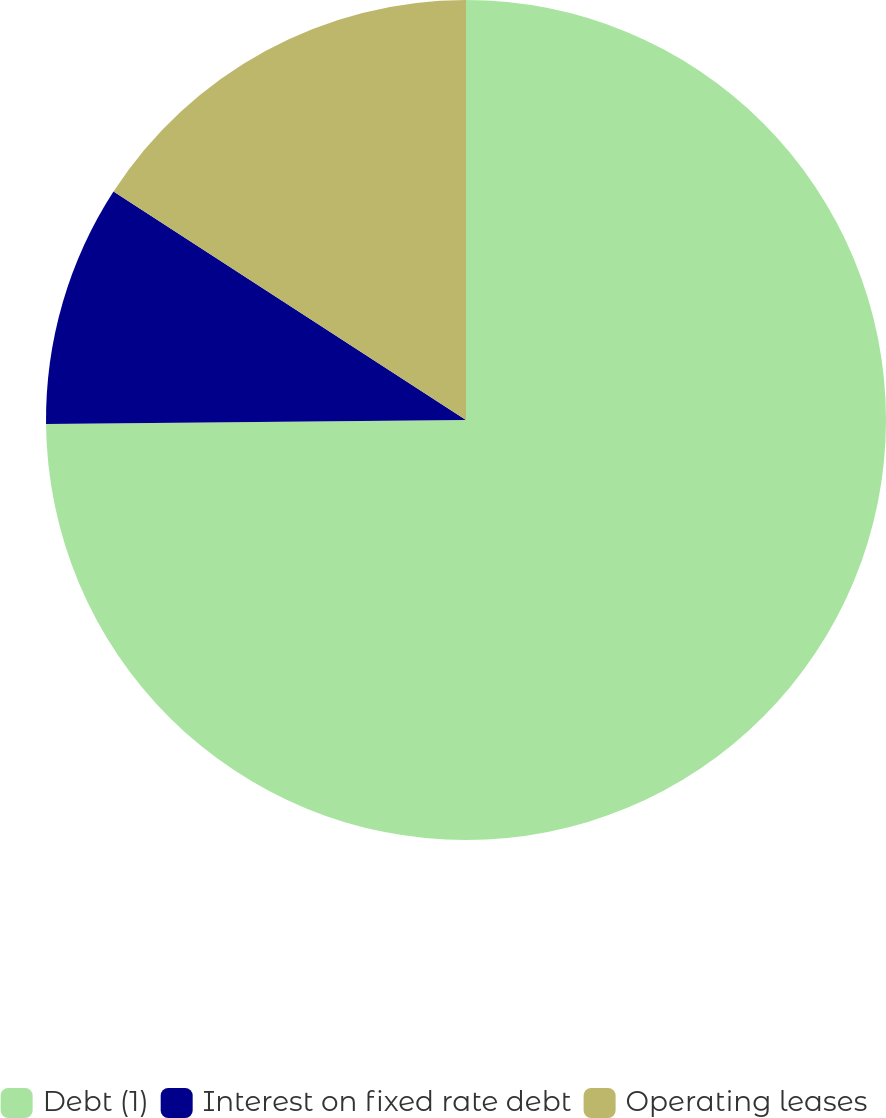Convert chart. <chart><loc_0><loc_0><loc_500><loc_500><pie_chart><fcel>Debt (1)<fcel>Interest on fixed rate debt<fcel>Operating leases<nl><fcel>74.85%<fcel>9.3%<fcel>15.85%<nl></chart> 